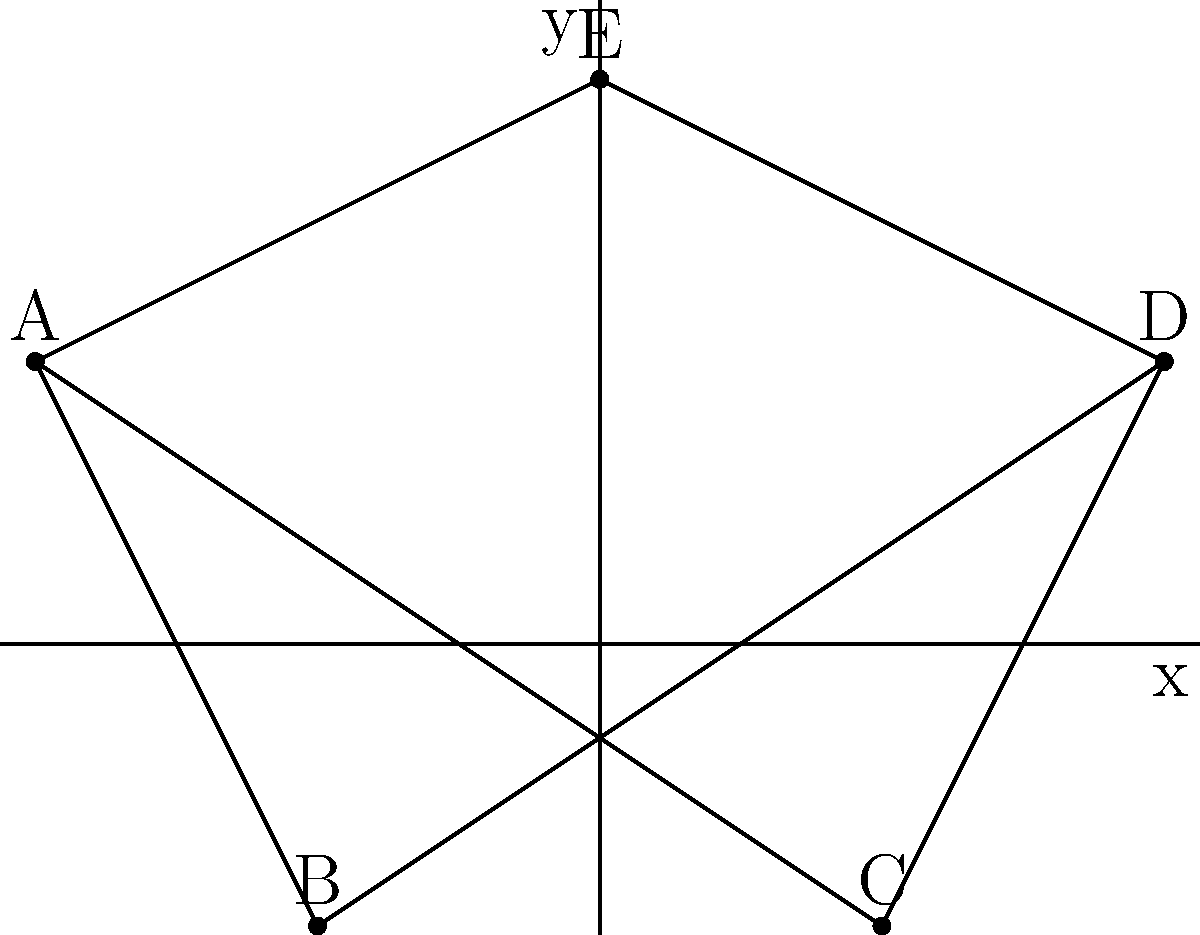In a study of social connections during a historical period, five key individuals (A, B, C, D, and E) are plotted on a coordinate plane based on their social influence and political alignment. The connections between these individuals are represented by lines. Calculate the total length of all social connections in this network, rounded to two decimal places. To solve this problem, we need to follow these steps:

1. Identify the coordinates of each individual:
   A: (-2, 1)
   B: (-1, -1)
   C: (1, -1)
   D: (2, 1)
   E: (0, 2)

2. Identify the connections:
   A-B, A-C, A-E, B-D, C-D, D-E

3. Calculate the length of each connection using the distance formula:
   $d = \sqrt{(x_2-x_1)^2 + (y_2-y_1)^2}$

   A-B: $\sqrt{(-1+2)^2 + (-1-1)^2} = \sqrt{1^2 + (-2)^2} = \sqrt{5}$
   A-C: $\sqrt{(1+2)^2 + (-1-1)^2} = \sqrt{3^2 + (-2)^2} = \sqrt{13}$
   A-E: $\sqrt{(0+2)^2 + (2-1)^2} = \sqrt{2^2 + 1^2} = \sqrt{5}$
   B-D: $\sqrt{(2+1)^2 + (1+1)^2} = \sqrt{3^2 + 2^2} = \sqrt{13}$
   C-D: $\sqrt{(2-1)^2 + (1+1)^2} = \sqrt{1^2 + 2^2} = \sqrt{5}$
   D-E: $\sqrt{(0-2)^2 + (2-1)^2} = \sqrt{(-2)^2 + 1^2} = \sqrt{5}$

4. Sum up all the lengths:
   Total length = $\sqrt{5} + \sqrt{13} + \sqrt{5} + \sqrt{13} + \sqrt{5} + \sqrt{5}$
                = $4\sqrt{5} + 2\sqrt{13}$

5. Simplify and calculate the numerical value:
   $4\sqrt{5} + 2\sqrt{13} \approx 8.94 + 7.21 = 16.15$

6. Round to two decimal places: 16.15
Answer: 16.15 